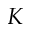<formula> <loc_0><loc_0><loc_500><loc_500>K</formula> 